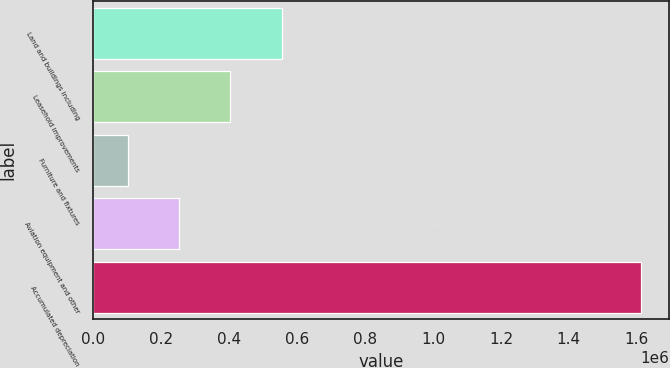Convert chart to OTSL. <chart><loc_0><loc_0><loc_500><loc_500><bar_chart><fcel>Land and buildings including<fcel>Leasehold improvements<fcel>Furniture and fixtures<fcel>Aviation equipment and other<fcel>Accumulated depreciation<nl><fcel>554490<fcel>403233<fcel>100717<fcel>251975<fcel>1.6133e+06<nl></chart> 